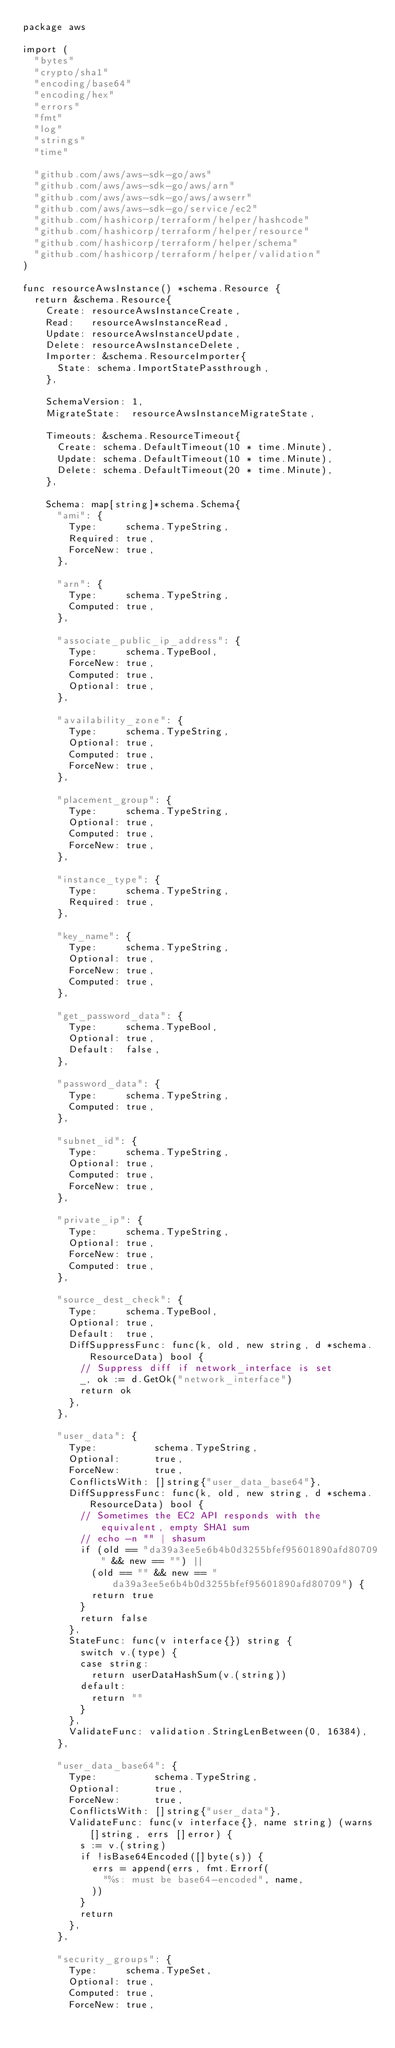<code> <loc_0><loc_0><loc_500><loc_500><_Go_>package aws

import (
	"bytes"
	"crypto/sha1"
	"encoding/base64"
	"encoding/hex"
	"errors"
	"fmt"
	"log"
	"strings"
	"time"

	"github.com/aws/aws-sdk-go/aws"
	"github.com/aws/aws-sdk-go/aws/arn"
	"github.com/aws/aws-sdk-go/aws/awserr"
	"github.com/aws/aws-sdk-go/service/ec2"
	"github.com/hashicorp/terraform/helper/hashcode"
	"github.com/hashicorp/terraform/helper/resource"
	"github.com/hashicorp/terraform/helper/schema"
	"github.com/hashicorp/terraform/helper/validation"
)

func resourceAwsInstance() *schema.Resource {
	return &schema.Resource{
		Create: resourceAwsInstanceCreate,
		Read:   resourceAwsInstanceRead,
		Update: resourceAwsInstanceUpdate,
		Delete: resourceAwsInstanceDelete,
		Importer: &schema.ResourceImporter{
			State: schema.ImportStatePassthrough,
		},

		SchemaVersion: 1,
		MigrateState:  resourceAwsInstanceMigrateState,

		Timeouts: &schema.ResourceTimeout{
			Create: schema.DefaultTimeout(10 * time.Minute),
			Update: schema.DefaultTimeout(10 * time.Minute),
			Delete: schema.DefaultTimeout(20 * time.Minute),
		},

		Schema: map[string]*schema.Schema{
			"ami": {
				Type:     schema.TypeString,
				Required: true,
				ForceNew: true,
			},

			"arn": {
				Type:     schema.TypeString,
				Computed: true,
			},

			"associate_public_ip_address": {
				Type:     schema.TypeBool,
				ForceNew: true,
				Computed: true,
				Optional: true,
			},

			"availability_zone": {
				Type:     schema.TypeString,
				Optional: true,
				Computed: true,
				ForceNew: true,
			},

			"placement_group": {
				Type:     schema.TypeString,
				Optional: true,
				Computed: true,
				ForceNew: true,
			},

			"instance_type": {
				Type:     schema.TypeString,
				Required: true,
			},

			"key_name": {
				Type:     schema.TypeString,
				Optional: true,
				ForceNew: true,
				Computed: true,
			},

			"get_password_data": {
				Type:     schema.TypeBool,
				Optional: true,
				Default:  false,
			},

			"password_data": {
				Type:     schema.TypeString,
				Computed: true,
			},

			"subnet_id": {
				Type:     schema.TypeString,
				Optional: true,
				Computed: true,
				ForceNew: true,
			},

			"private_ip": {
				Type:     schema.TypeString,
				Optional: true,
				ForceNew: true,
				Computed: true,
			},

			"source_dest_check": {
				Type:     schema.TypeBool,
				Optional: true,
				Default:  true,
				DiffSuppressFunc: func(k, old, new string, d *schema.ResourceData) bool {
					// Suppress diff if network_interface is set
					_, ok := d.GetOk("network_interface")
					return ok
				},
			},

			"user_data": {
				Type:          schema.TypeString,
				Optional:      true,
				ForceNew:      true,
				ConflictsWith: []string{"user_data_base64"},
				DiffSuppressFunc: func(k, old, new string, d *schema.ResourceData) bool {
					// Sometimes the EC2 API responds with the equivalent, empty SHA1 sum
					// echo -n "" | shasum
					if (old == "da39a3ee5e6b4b0d3255bfef95601890afd80709" && new == "") ||
						(old == "" && new == "da39a3ee5e6b4b0d3255bfef95601890afd80709") {
						return true
					}
					return false
				},
				StateFunc: func(v interface{}) string {
					switch v.(type) {
					case string:
						return userDataHashSum(v.(string))
					default:
						return ""
					}
				},
				ValidateFunc: validation.StringLenBetween(0, 16384),
			},

			"user_data_base64": {
				Type:          schema.TypeString,
				Optional:      true,
				ForceNew:      true,
				ConflictsWith: []string{"user_data"},
				ValidateFunc: func(v interface{}, name string) (warns []string, errs []error) {
					s := v.(string)
					if !isBase64Encoded([]byte(s)) {
						errs = append(errs, fmt.Errorf(
							"%s: must be base64-encoded", name,
						))
					}
					return
				},
			},

			"security_groups": {
				Type:     schema.TypeSet,
				Optional: true,
				Computed: true,
				ForceNew: true,</code> 